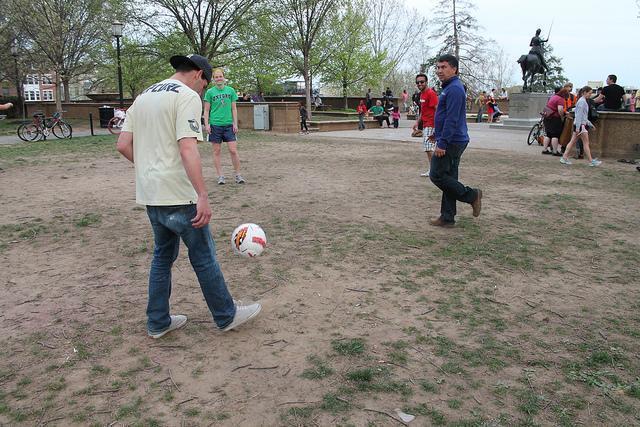What sport other that the ball's proper sport does the ball look closest to belonging to?
Select the accurate response from the four choices given to answer the question.
Options: American football, volleyball, golf, tennis. Volleyball. 